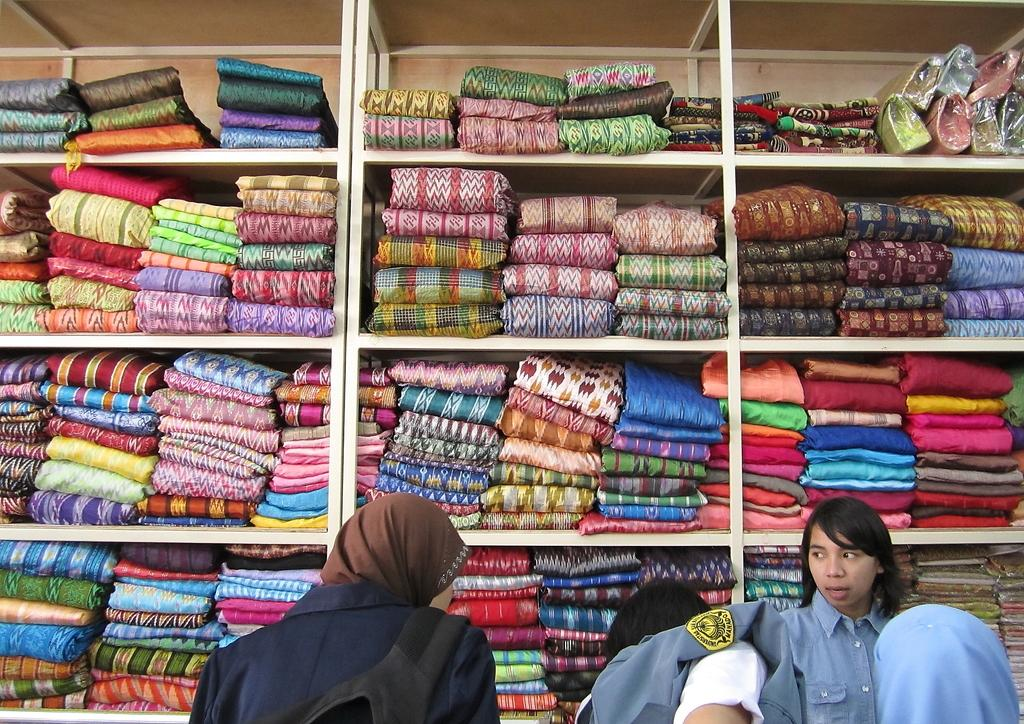Who or what can be seen at the bottom of the image? There are people at the bottom of the image. What is located behind the people in the image? There are many folded clothes arranged in racks at the back of the people. What type of animals can be seen at the zoo in the image? There is no zoo or animals present in the image; it features people and folded clothes arranged in racks. 